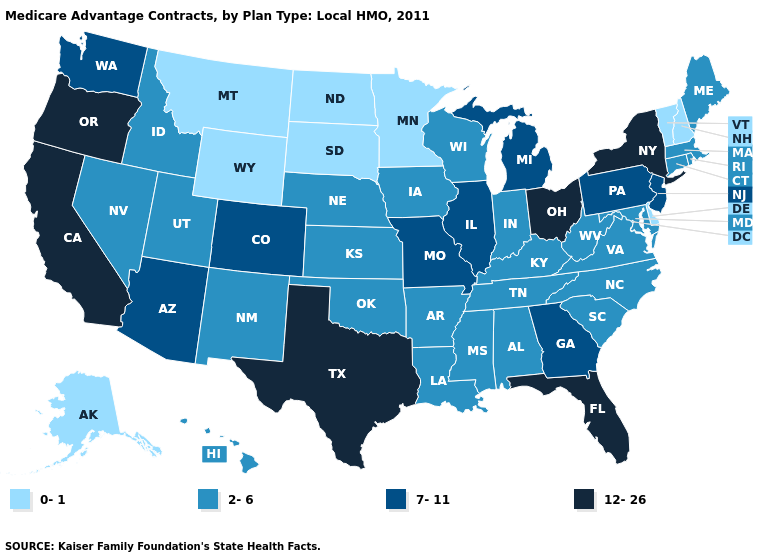What is the lowest value in the Northeast?
Short answer required. 0-1. Name the states that have a value in the range 7-11?
Give a very brief answer. Arizona, Colorado, Georgia, Illinois, Michigan, Missouri, New Jersey, Pennsylvania, Washington. What is the lowest value in the USA?
Quick response, please. 0-1. What is the lowest value in the West?
Short answer required. 0-1. Which states hav the highest value in the MidWest?
Answer briefly. Ohio. Does Mississippi have the same value as South Dakota?
Answer briefly. No. Does the map have missing data?
Write a very short answer. No. What is the highest value in states that border Virginia?
Keep it brief. 2-6. What is the value of Ohio?
Be succinct. 12-26. Name the states that have a value in the range 2-6?
Be succinct. Alabama, Arkansas, Connecticut, Hawaii, Iowa, Idaho, Indiana, Kansas, Kentucky, Louisiana, Massachusetts, Maryland, Maine, Mississippi, North Carolina, Nebraska, New Mexico, Nevada, Oklahoma, Rhode Island, South Carolina, Tennessee, Utah, Virginia, Wisconsin, West Virginia. What is the lowest value in states that border Missouri?
Write a very short answer. 2-6. What is the lowest value in states that border North Dakota?
Write a very short answer. 0-1. Name the states that have a value in the range 12-26?
Quick response, please. California, Florida, New York, Ohio, Oregon, Texas. Does Texas have the highest value in the USA?
Short answer required. Yes. Does Minnesota have the lowest value in the USA?
Short answer required. Yes. 